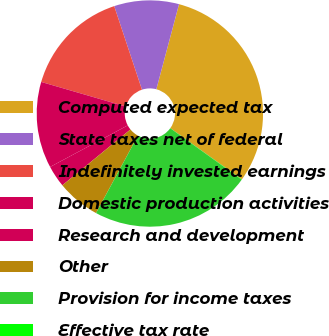<chart> <loc_0><loc_0><loc_500><loc_500><pie_chart><fcel>Computed expected tax<fcel>State taxes net of federal<fcel>Indefinitely invested earnings<fcel>Domestic production activities<fcel>Research and development<fcel>Other<fcel>Provision for income taxes<fcel>Effective tax rate<nl><fcel>30.74%<fcel>9.25%<fcel>15.39%<fcel>12.32%<fcel>3.11%<fcel>6.18%<fcel>22.95%<fcel>0.04%<nl></chart> 